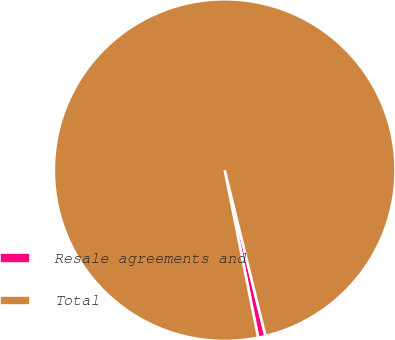Convert chart to OTSL. <chart><loc_0><loc_0><loc_500><loc_500><pie_chart><fcel>Resale agreements and<fcel>Total<nl><fcel>0.7%<fcel>99.3%<nl></chart> 